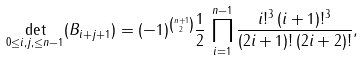Convert formula to latex. <formula><loc_0><loc_0><loc_500><loc_500>\det _ { 0 \leq i , j , \leq n - 1 } ( B _ { i + j + 1 } ) = ( - 1 ) ^ { \binom { n + 1 } 2 } \frac { 1 } { 2 } \, \prod _ { i = 1 } ^ { n - 1 } \frac { i ! ^ { 3 } \, ( i + 1 ) ! ^ { 3 } } { ( 2 i + 1 ) ! \, ( 2 i + 2 ) ! } ,</formula> 